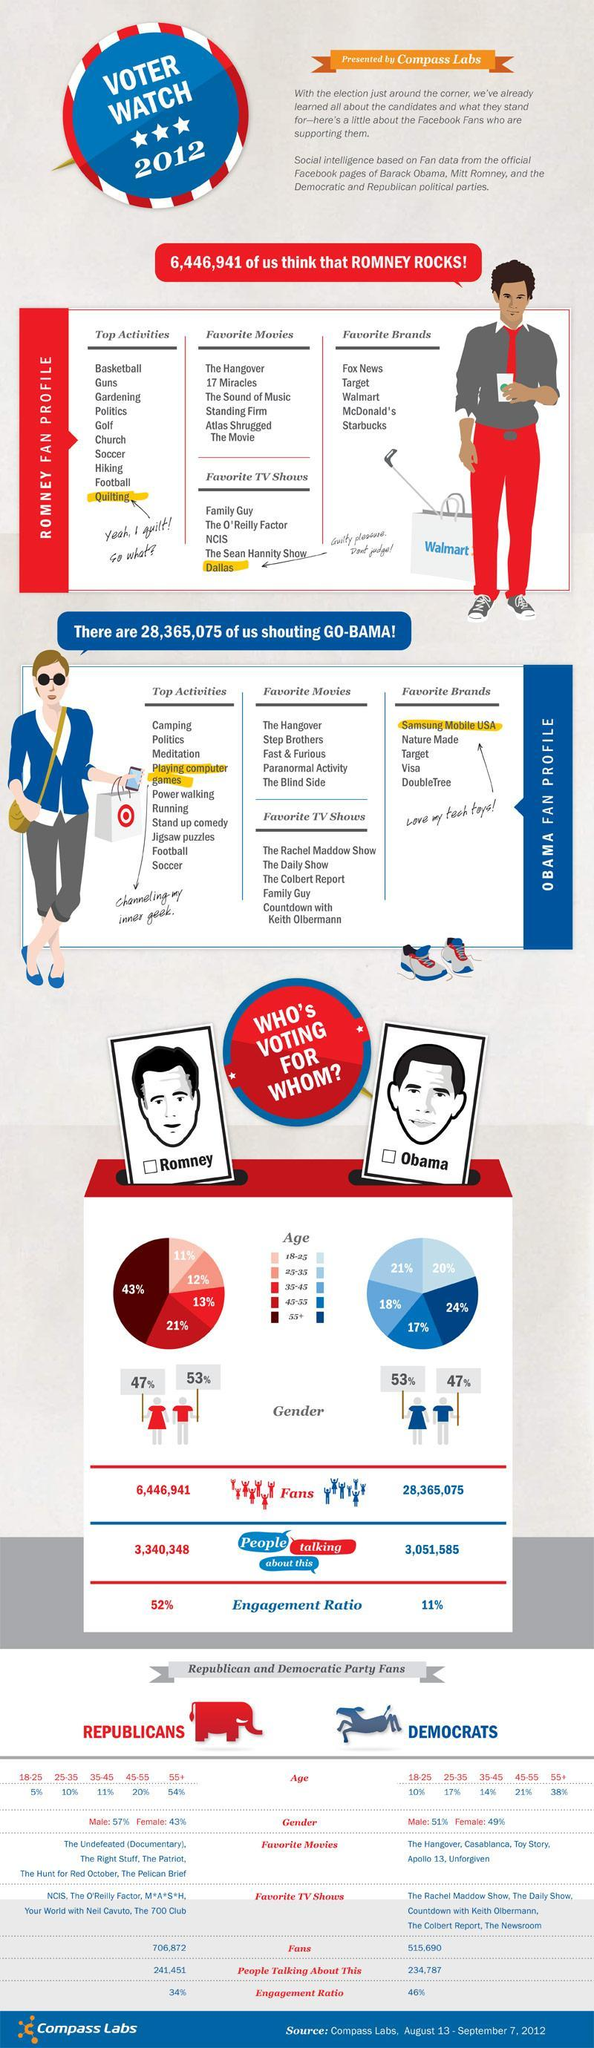What percent of women are voting for Obama?
Answer the question with a short phrase. 53% What is the engagement ratio of those favouring Obama? 11% 21% of people voting for Mitt Romney come under which age group? 45-55 How many fans does Obama have? 28,365,075 What percent of people voting for Obama are senior citizens? 24% What percent of people voting for Romney are in the age group 25-35? 12% Which animal represents Republican- elephant or horse? elephant What percent of men will vote for Romney? 53% How many people are talking about voting for Romney? 3,340,348 